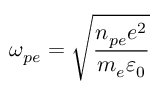Convert formula to latex. <formula><loc_0><loc_0><loc_500><loc_500>\omega _ { p e } = \sqrt { \frac { n _ { p e } e ^ { 2 } } { m _ { e } \varepsilon _ { 0 } } }</formula> 